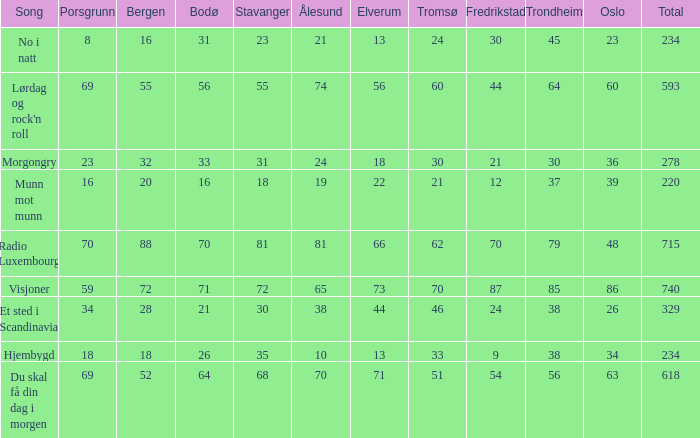What was the total for radio luxembourg? 715.0. 